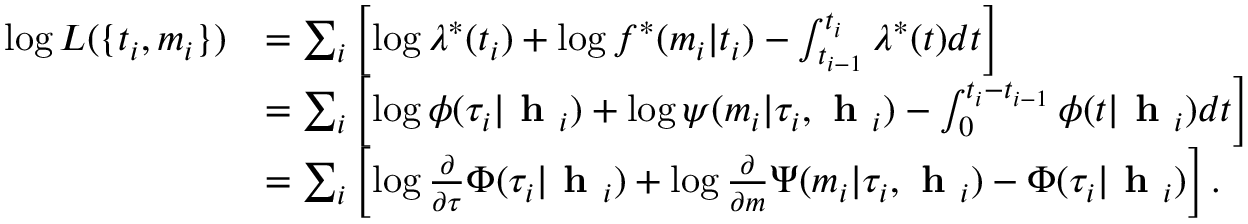Convert formula to latex. <formula><loc_0><loc_0><loc_500><loc_500>\begin{array} { r l } { \log L ( \{ t _ { i } , m _ { i } \} ) } & { = \sum _ { i } \left [ \log \lambda ^ { * } ( t _ { i } ) + \log f ^ { * } ( m _ { i } | t _ { i } ) - \int _ { t _ { i - 1 } } ^ { t _ { i } } \lambda ^ { * } ( t ) d t \right ] } \\ & { = \sum _ { i } \left [ \log \phi ( \tau _ { i } | h _ { i } ) + \log \psi ( m _ { i } | \tau _ { i } , h _ { i } ) - \int _ { 0 } ^ { t _ { i } - t _ { i - 1 } } \phi ( t | h _ { i } ) d t \right ] } \\ & { = \sum _ { i } \left [ \log \frac { \partial } { \partial \tau } \Phi ( \tau _ { i } | h _ { i } ) + \log \frac { \partial } { \partial m } \Psi ( m _ { i } | \tau _ { i } , h _ { i } ) - \Phi ( \tau _ { i } | h _ { i } ) \right ] . } \end{array}</formula> 